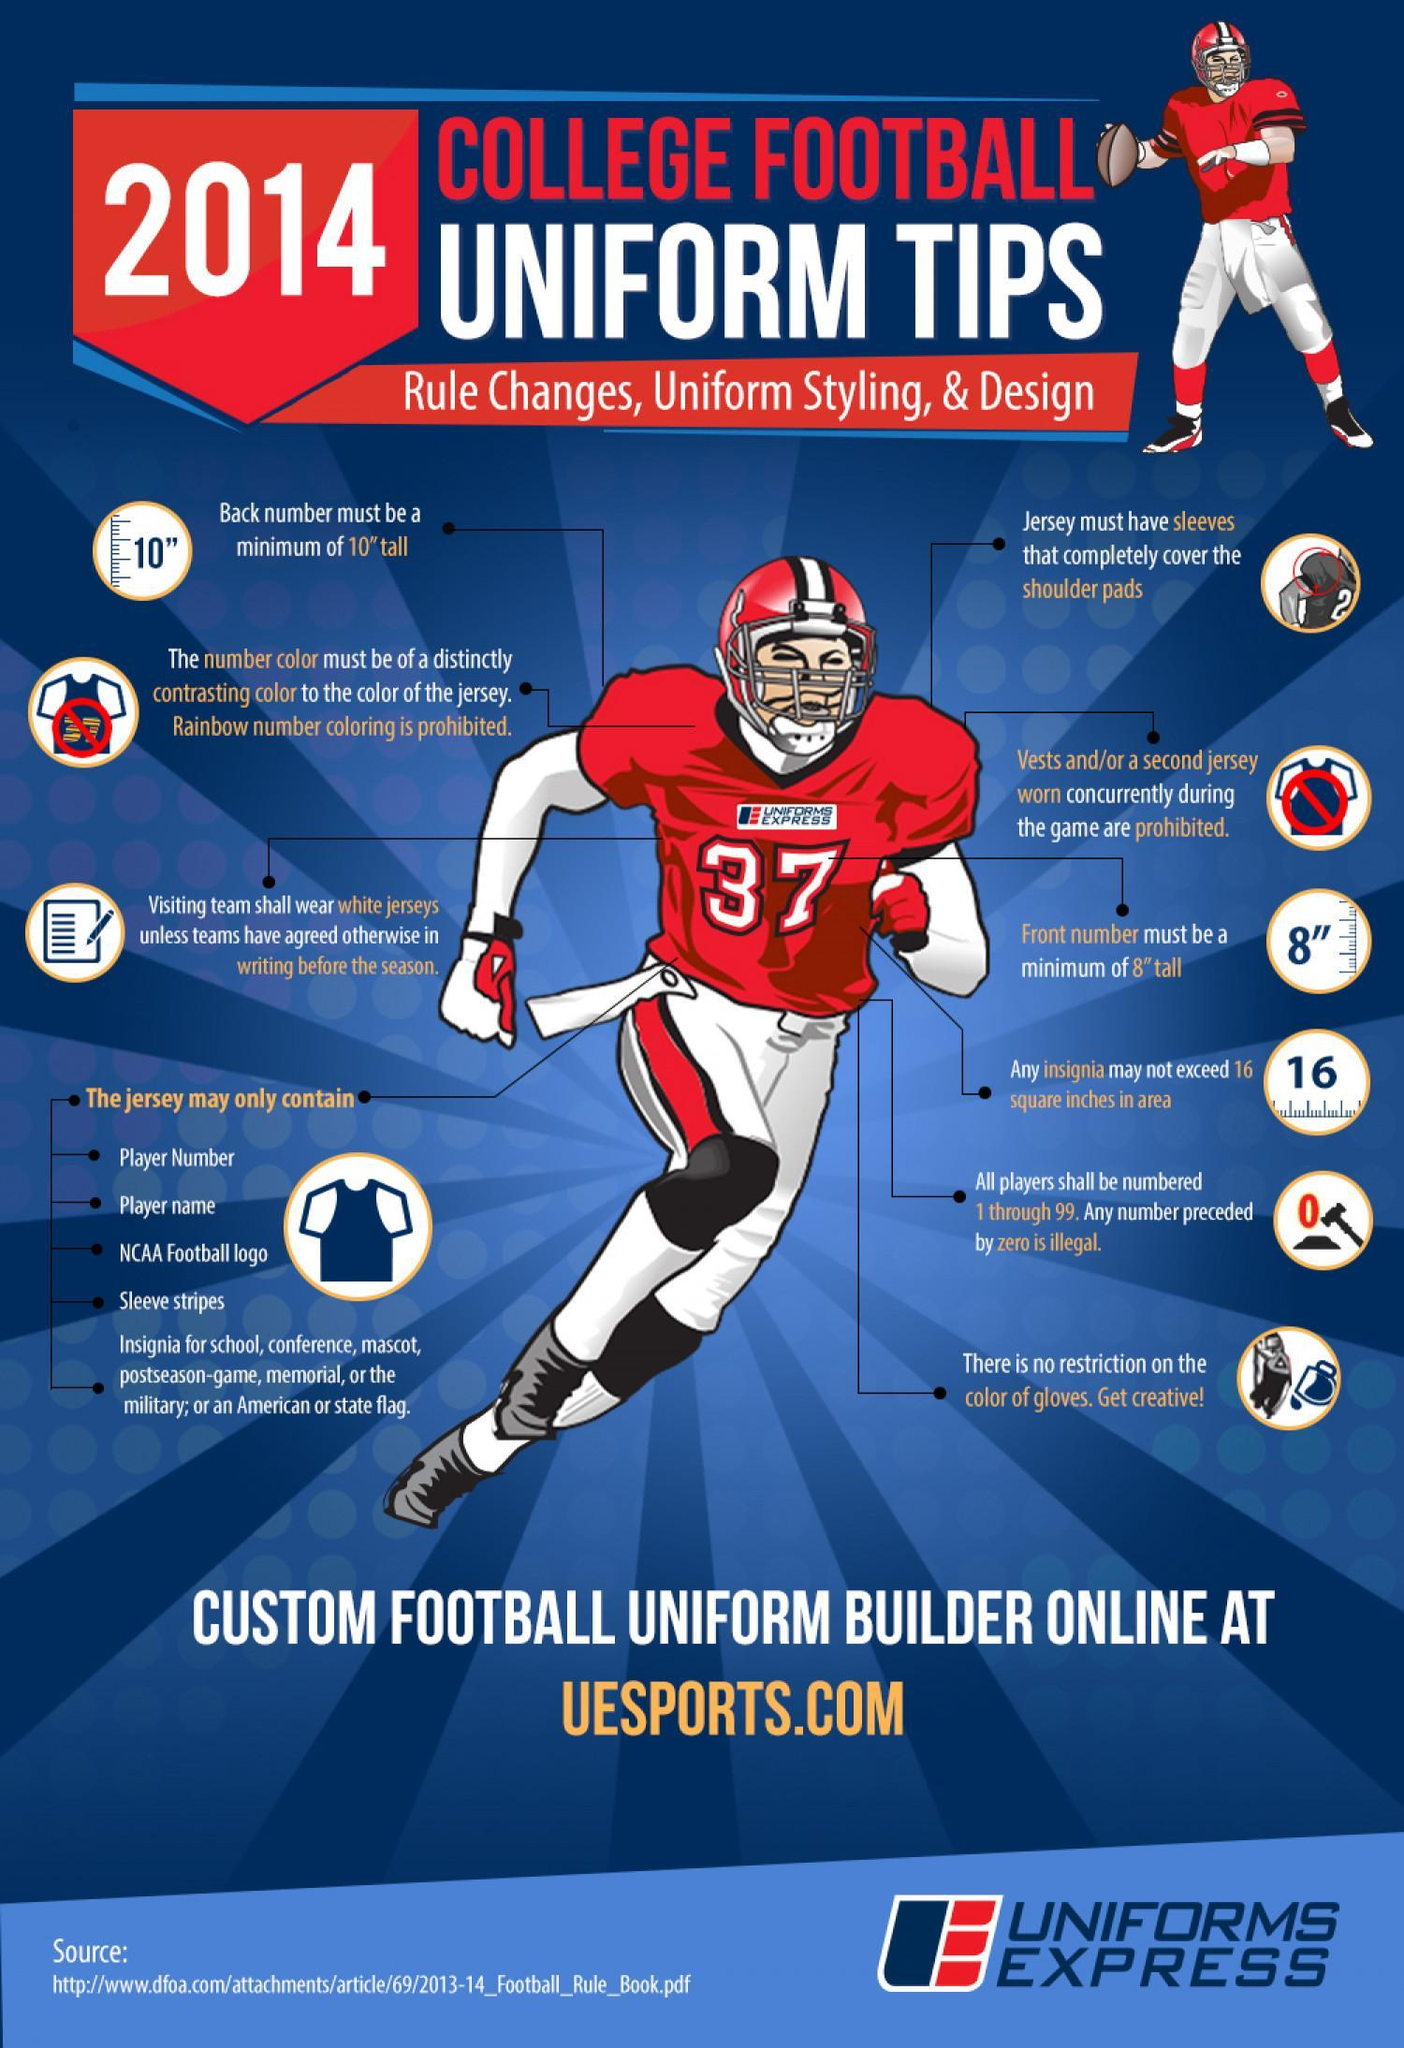whether back number or front number on the jersey should be a minimum of 10" tall?
Answer the question with a short phrase. back number what is the colour of jersey shown in the picture, white or red? white whether back number or front number on the jersey should be a minimum of 8" tall? front number 